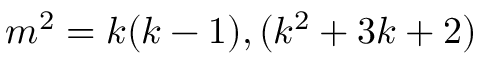<formula> <loc_0><loc_0><loc_500><loc_500>m ^ { 2 } = k ( k - 1 ) , ( k ^ { 2 } + 3 k + 2 )</formula> 